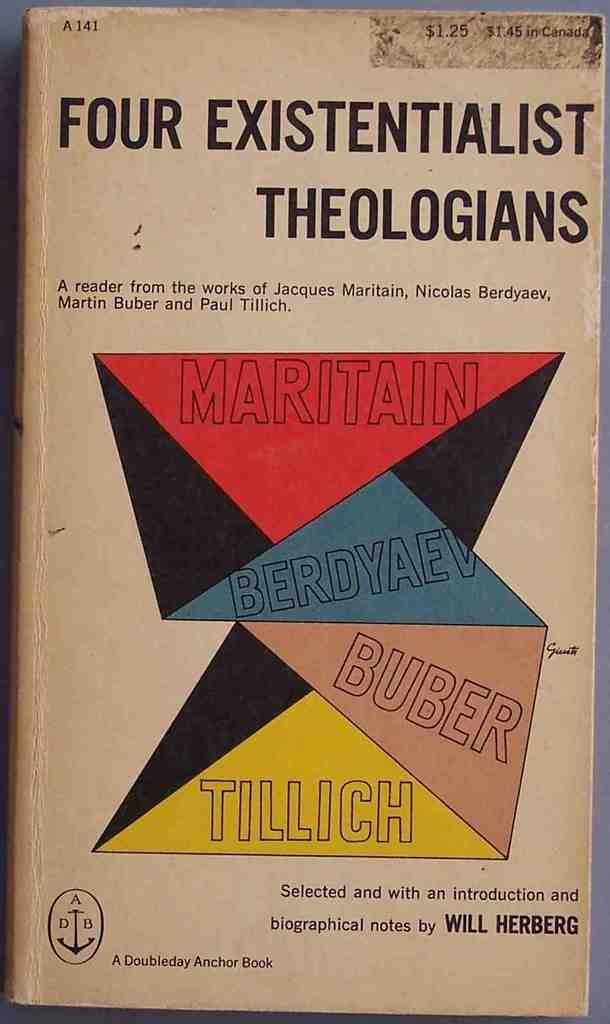<image>
Summarize the visual content of the image. A book with selected works from 4 theologians is displayed. 